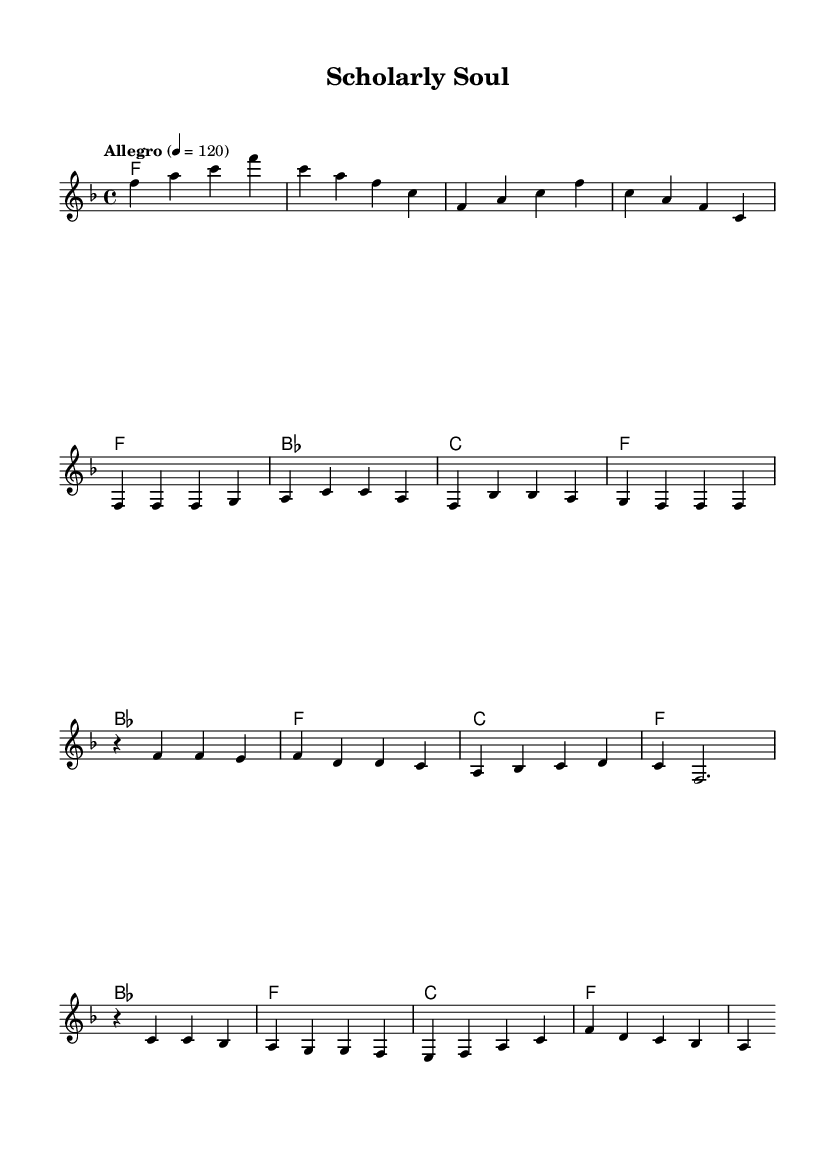What is the key signature of this music? The key signature is F major, which has one flat (B flat).
Answer: F major What is the time signature of this music? The time signature is 4/4, indicating four beats per measure.
Answer: 4/4 What is the tempo marking of the music? The tempo marking indicates "Allegro," which suggests a lively and fast-paced performance.
Answer: Allegro What are the first three notes of the melody? The first three notes are F, A, and C, as seen in the initial measures of the melody.
Answer: F, A, C How many measures are there in the chorus section? The chorus consists of four measures, indicated by the grouping of notes and rests.
Answer: 4 Which chord is played in the last measure of the introduction? The last measure of the introduction shows the F chord being played.
Answer: F What is the highest note in the melody? The highest note in the melody is C in the bridge section, which can be identified by its position on the staff.
Answer: C 